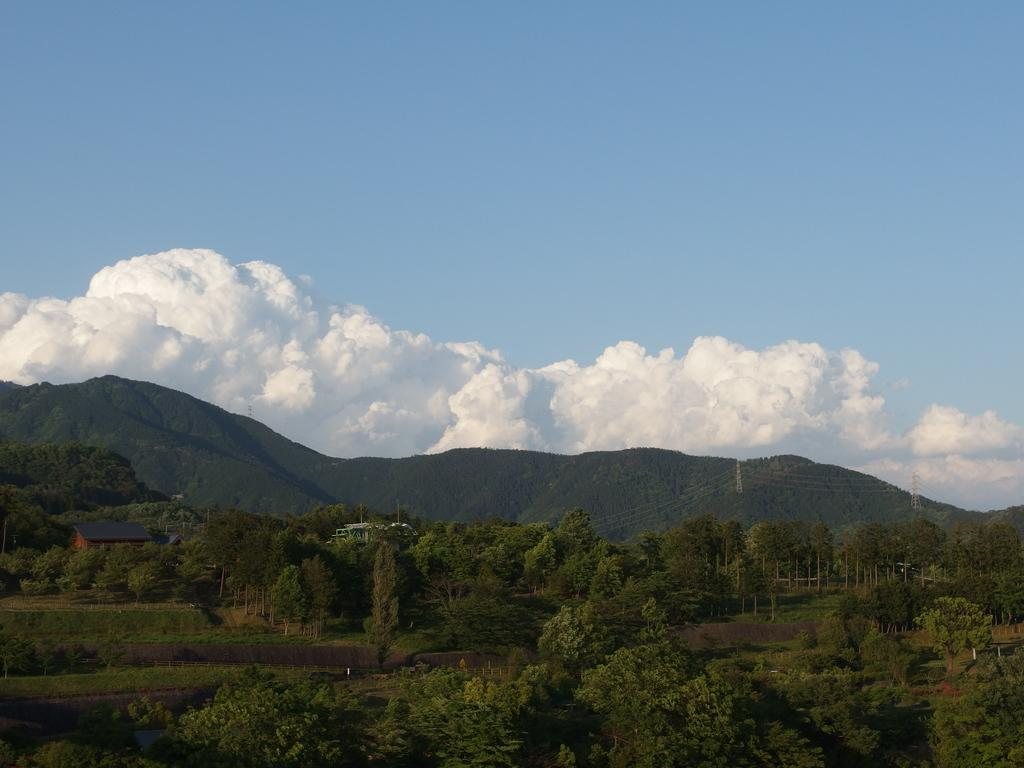What type of structures are present in the image? There are cell towers in the image. What else can be seen in the image besides the cell towers? There are buildings, trees, plants, and hills visible in the image. What is visible at the top of the image? The sky is visible in the image. What type of trick can be seen being performed with the corn in the image? There is no corn or trick present in the image. What type of discovery can be made by examining the plants in the image? There is no discovery to be made by examining the plants in the image; they are simply visible. 